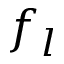<formula> <loc_0><loc_0><loc_500><loc_500>f _ { l }</formula> 